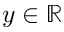<formula> <loc_0><loc_0><loc_500><loc_500>y \in \mathbb { R }</formula> 